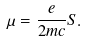<formula> <loc_0><loc_0><loc_500><loc_500>\mu = \frac { e } { 2 m c } S .</formula> 